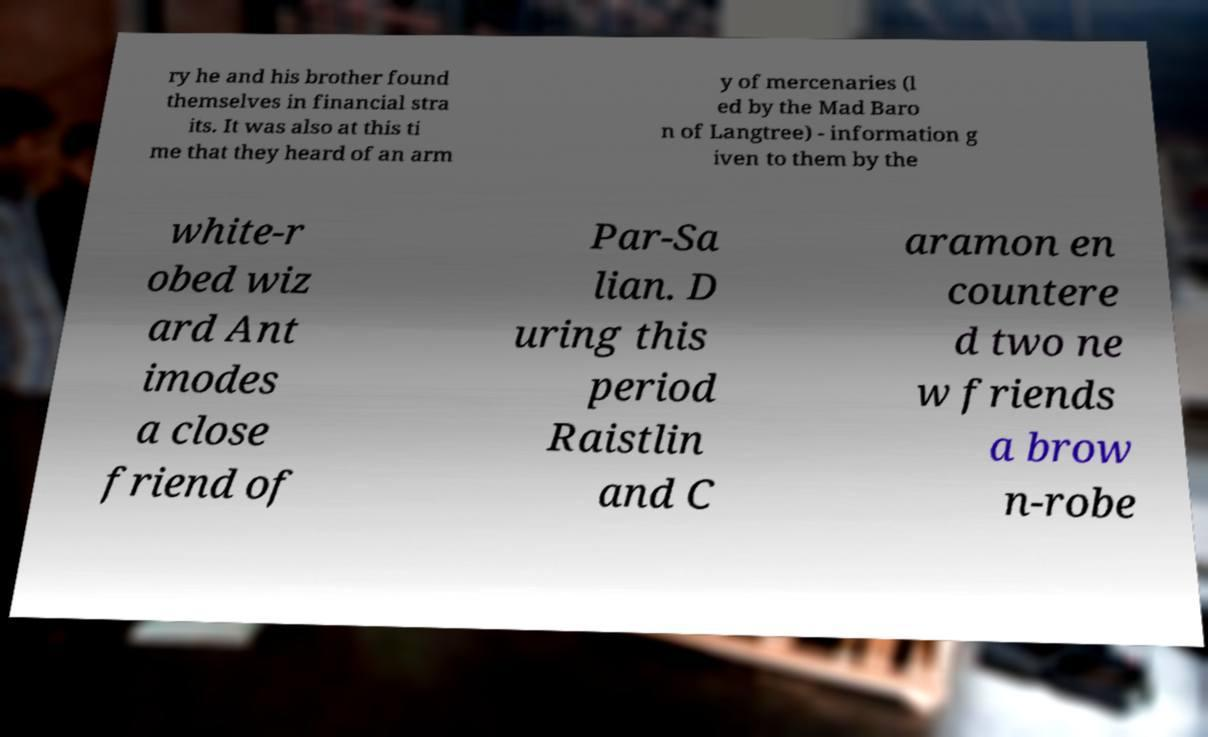Please read and relay the text visible in this image. What does it say? ry he and his brother found themselves in financial stra its. It was also at this ti me that they heard of an arm y of mercenaries (l ed by the Mad Baro n of Langtree) - information g iven to them by the white-r obed wiz ard Ant imodes a close friend of Par-Sa lian. D uring this period Raistlin and C aramon en countere d two ne w friends a brow n-robe 